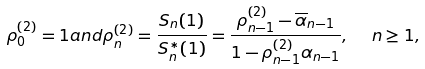<formula> <loc_0><loc_0><loc_500><loc_500>\rho _ { 0 } ^ { ( 2 ) } = 1 a n d \rho _ { n } ^ { ( 2 ) } = \frac { S _ { n } ( 1 ) } { S _ { n } ^ { \ast } ( 1 ) } = \frac { \rho _ { n - 1 } ^ { ( 2 ) } - \overline { \alpha } _ { n - 1 } } { 1 - \rho _ { n - 1 } ^ { ( 2 ) } \alpha _ { n - 1 } } , \ \ n \geq 1 ,</formula> 